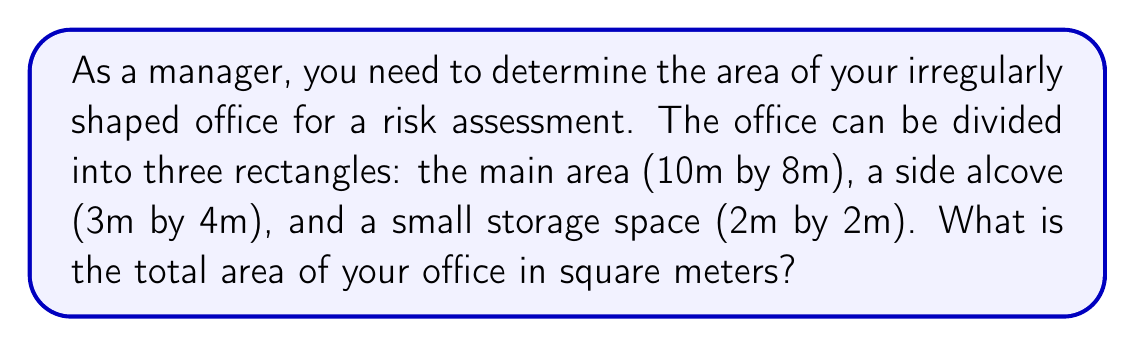What is the answer to this math problem? To solve this problem, we'll follow these steps:

1. Calculate the area of each rectangular section:

   a. Main area: 
      $$A_1 = 10\text{m} \times 8\text{m} = 80\text{m}^2$$

   b. Side alcove:
      $$A_2 = 3\text{m} \times 4\text{m} = 12\text{m}^2$$

   c. Storage space:
      $$A_3 = 2\text{m} \times 2\text{m} = 4\text{m}^2$$

2. Sum up the areas of all sections:
   $$A_{\text{total}} = A_1 + A_2 + A_3$$
   $$A_{\text{total}} = 80\text{m}^2 + 12\text{m}^2 + 4\text{m}^2 = 96\text{m}^2$$

Therefore, the total area of the irregularly shaped office is 96 square meters.

[asy]
unitsize(5mm);
draw((0,0)--(10,0)--(10,8)--(0,8)--cycle);
draw((10,0)--(13,0)--(13,4)--(10,4));
draw((13,0)--(15,0)--(15,2)--(13,2));
label("10m", (5,-0.5));
label("8m", (10.5,4));
label("3m", (11.5,-0.5));
label("4m", (13.5,2));
label("2m", (14,-0.5));
label("2m", (15.5,1));
[/asy]
Answer: 96m² 